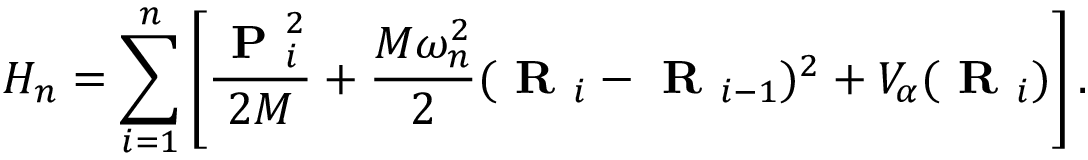<formula> <loc_0><loc_0><loc_500><loc_500>H _ { n } = \sum _ { i = 1 } ^ { n } \left [ \frac { P _ { i } ^ { 2 } } { 2 M } + \frac { M \omega _ { n } ^ { 2 } } { 2 } ( R _ { i } - R _ { i - 1 } ) ^ { 2 } + V _ { \alpha } ( R _ { i } ) \right ] .</formula> 